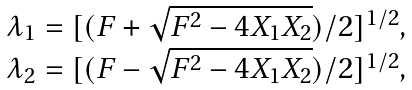<formula> <loc_0><loc_0><loc_500><loc_500>\begin{array} { c } \lambda _ { 1 } = [ ( F + { \sqrt { F ^ { 2 } - 4 X _ { 1 } X _ { 2 } } } ) / 2 ] ^ { 1 / 2 } , \\ \lambda _ { 2 } = [ ( F - { \sqrt { F ^ { 2 } - 4 X _ { 1 } X _ { 2 } } } ) / 2 ] ^ { 1 / 2 } , \end{array}</formula> 